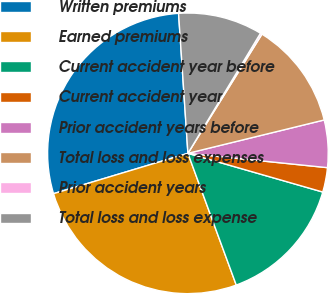<chart> <loc_0><loc_0><loc_500><loc_500><pie_chart><fcel>Written premiums<fcel>Earned premiums<fcel>Current accident year before<fcel>Current accident year<fcel>Prior accident years before<fcel>Total loss and loss expenses<fcel>Prior accident years<fcel>Total loss and loss expense<nl><fcel>28.58%<fcel>25.96%<fcel>14.95%<fcel>2.82%<fcel>5.45%<fcel>12.33%<fcel>0.2%<fcel>9.71%<nl></chart> 